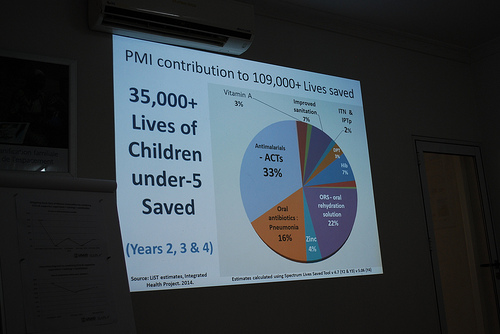<image>
Is the center in the circumference? Yes. The center is contained within or inside the circumference, showing a containment relationship. 